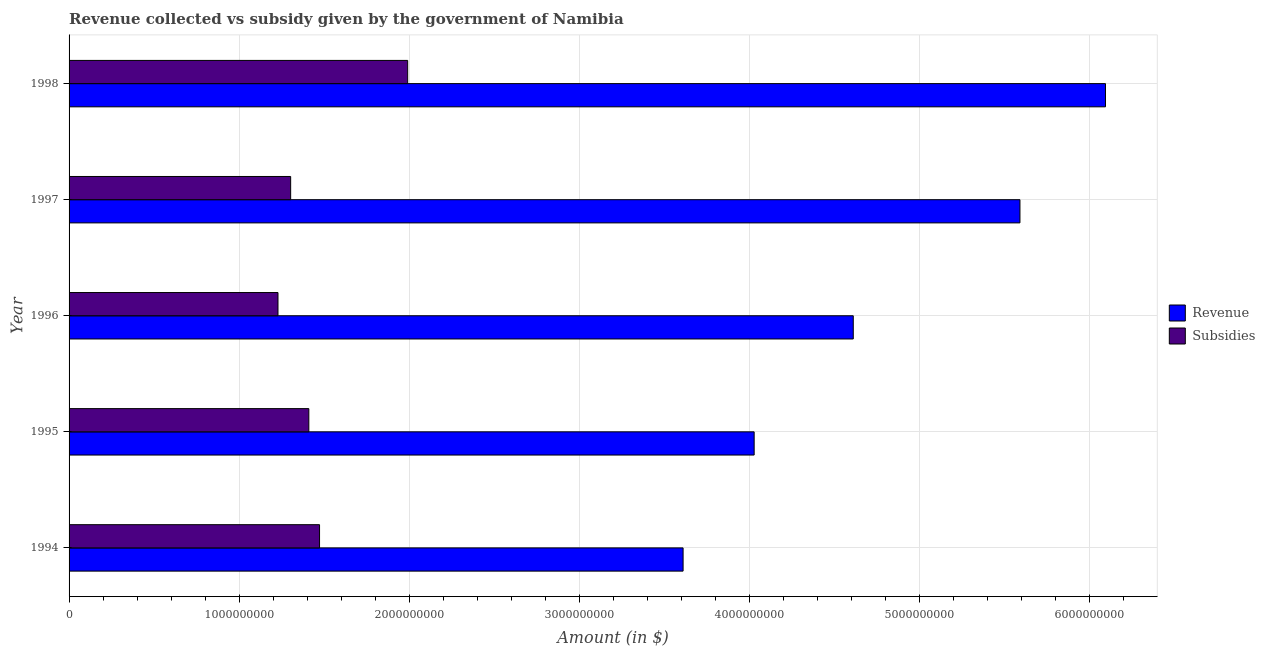How many groups of bars are there?
Give a very brief answer. 5. Are the number of bars on each tick of the Y-axis equal?
Your answer should be very brief. Yes. How many bars are there on the 4th tick from the top?
Give a very brief answer. 2. How many bars are there on the 4th tick from the bottom?
Keep it short and to the point. 2. What is the amount of subsidies given in 1996?
Provide a short and direct response. 1.23e+09. Across all years, what is the maximum amount of subsidies given?
Give a very brief answer. 1.99e+09. Across all years, what is the minimum amount of subsidies given?
Your answer should be compact. 1.23e+09. In which year was the amount of revenue collected maximum?
Make the answer very short. 1998. In which year was the amount of revenue collected minimum?
Ensure brevity in your answer.  1994. What is the total amount of subsidies given in the graph?
Offer a very short reply. 7.41e+09. What is the difference between the amount of subsidies given in 1994 and that in 1995?
Offer a very short reply. 6.31e+07. What is the difference between the amount of subsidies given in 1997 and the amount of revenue collected in 1996?
Keep it short and to the point. -3.31e+09. What is the average amount of revenue collected per year?
Provide a short and direct response. 4.79e+09. In the year 1998, what is the difference between the amount of subsidies given and amount of revenue collected?
Provide a short and direct response. -4.10e+09. What is the ratio of the amount of subsidies given in 1994 to that in 1997?
Your answer should be compact. 1.13. What is the difference between the highest and the second highest amount of subsidies given?
Keep it short and to the point. 5.18e+08. What is the difference between the highest and the lowest amount of subsidies given?
Give a very brief answer. 7.63e+08. Is the sum of the amount of subsidies given in 1994 and 1996 greater than the maximum amount of revenue collected across all years?
Make the answer very short. No. What does the 2nd bar from the top in 1996 represents?
Your answer should be compact. Revenue. What does the 2nd bar from the bottom in 1998 represents?
Provide a succinct answer. Subsidies. How many bars are there?
Offer a terse response. 10. How many years are there in the graph?
Make the answer very short. 5. Are the values on the major ticks of X-axis written in scientific E-notation?
Make the answer very short. No. Does the graph contain grids?
Ensure brevity in your answer.  Yes. How many legend labels are there?
Your response must be concise. 2. What is the title of the graph?
Ensure brevity in your answer.  Revenue collected vs subsidy given by the government of Namibia. What is the label or title of the X-axis?
Provide a succinct answer. Amount (in $). What is the label or title of the Y-axis?
Keep it short and to the point. Year. What is the Amount (in $) in Revenue in 1994?
Keep it short and to the point. 3.61e+09. What is the Amount (in $) in Subsidies in 1994?
Provide a succinct answer. 1.47e+09. What is the Amount (in $) of Revenue in 1995?
Offer a terse response. 4.03e+09. What is the Amount (in $) of Subsidies in 1995?
Your answer should be very brief. 1.41e+09. What is the Amount (in $) of Revenue in 1996?
Give a very brief answer. 4.61e+09. What is the Amount (in $) of Subsidies in 1996?
Provide a succinct answer. 1.23e+09. What is the Amount (in $) of Revenue in 1997?
Ensure brevity in your answer.  5.59e+09. What is the Amount (in $) of Subsidies in 1997?
Your answer should be compact. 1.30e+09. What is the Amount (in $) of Revenue in 1998?
Your response must be concise. 6.09e+09. What is the Amount (in $) in Subsidies in 1998?
Your answer should be very brief. 1.99e+09. Across all years, what is the maximum Amount (in $) of Revenue?
Keep it short and to the point. 6.09e+09. Across all years, what is the maximum Amount (in $) in Subsidies?
Your response must be concise. 1.99e+09. Across all years, what is the minimum Amount (in $) of Revenue?
Offer a terse response. 3.61e+09. Across all years, what is the minimum Amount (in $) of Subsidies?
Give a very brief answer. 1.23e+09. What is the total Amount (in $) in Revenue in the graph?
Your answer should be compact. 2.39e+1. What is the total Amount (in $) of Subsidies in the graph?
Make the answer very short. 7.41e+09. What is the difference between the Amount (in $) in Revenue in 1994 and that in 1995?
Make the answer very short. -4.18e+08. What is the difference between the Amount (in $) in Subsidies in 1994 and that in 1995?
Keep it short and to the point. 6.31e+07. What is the difference between the Amount (in $) of Revenue in 1994 and that in 1996?
Keep it short and to the point. -1.00e+09. What is the difference between the Amount (in $) of Subsidies in 1994 and that in 1996?
Ensure brevity in your answer.  2.44e+08. What is the difference between the Amount (in $) in Revenue in 1994 and that in 1997?
Provide a short and direct response. -1.98e+09. What is the difference between the Amount (in $) of Subsidies in 1994 and that in 1997?
Offer a very short reply. 1.70e+08. What is the difference between the Amount (in $) in Revenue in 1994 and that in 1998?
Offer a very short reply. -2.48e+09. What is the difference between the Amount (in $) of Subsidies in 1994 and that in 1998?
Offer a terse response. -5.18e+08. What is the difference between the Amount (in $) in Revenue in 1995 and that in 1996?
Your answer should be compact. -5.83e+08. What is the difference between the Amount (in $) of Subsidies in 1995 and that in 1996?
Offer a terse response. 1.81e+08. What is the difference between the Amount (in $) in Revenue in 1995 and that in 1997?
Your response must be concise. -1.56e+09. What is the difference between the Amount (in $) of Subsidies in 1995 and that in 1997?
Your response must be concise. 1.07e+08. What is the difference between the Amount (in $) in Revenue in 1995 and that in 1998?
Make the answer very short. -2.07e+09. What is the difference between the Amount (in $) of Subsidies in 1995 and that in 1998?
Your response must be concise. -5.81e+08. What is the difference between the Amount (in $) of Revenue in 1996 and that in 1997?
Your answer should be very brief. -9.80e+08. What is the difference between the Amount (in $) in Subsidies in 1996 and that in 1997?
Offer a terse response. -7.44e+07. What is the difference between the Amount (in $) of Revenue in 1996 and that in 1998?
Your response must be concise. -1.48e+09. What is the difference between the Amount (in $) of Subsidies in 1996 and that in 1998?
Keep it short and to the point. -7.63e+08. What is the difference between the Amount (in $) of Revenue in 1997 and that in 1998?
Ensure brevity in your answer.  -5.03e+08. What is the difference between the Amount (in $) of Subsidies in 1997 and that in 1998?
Your answer should be compact. -6.88e+08. What is the difference between the Amount (in $) of Revenue in 1994 and the Amount (in $) of Subsidies in 1995?
Offer a terse response. 2.20e+09. What is the difference between the Amount (in $) of Revenue in 1994 and the Amount (in $) of Subsidies in 1996?
Offer a very short reply. 2.38e+09. What is the difference between the Amount (in $) of Revenue in 1994 and the Amount (in $) of Subsidies in 1997?
Ensure brevity in your answer.  2.31e+09. What is the difference between the Amount (in $) in Revenue in 1994 and the Amount (in $) in Subsidies in 1998?
Your response must be concise. 1.62e+09. What is the difference between the Amount (in $) of Revenue in 1995 and the Amount (in $) of Subsidies in 1996?
Keep it short and to the point. 2.80e+09. What is the difference between the Amount (in $) of Revenue in 1995 and the Amount (in $) of Subsidies in 1997?
Ensure brevity in your answer.  2.73e+09. What is the difference between the Amount (in $) of Revenue in 1995 and the Amount (in $) of Subsidies in 1998?
Keep it short and to the point. 2.04e+09. What is the difference between the Amount (in $) in Revenue in 1996 and the Amount (in $) in Subsidies in 1997?
Provide a succinct answer. 3.31e+09. What is the difference between the Amount (in $) of Revenue in 1996 and the Amount (in $) of Subsidies in 1998?
Your answer should be compact. 2.62e+09. What is the difference between the Amount (in $) of Revenue in 1997 and the Amount (in $) of Subsidies in 1998?
Keep it short and to the point. 3.60e+09. What is the average Amount (in $) in Revenue per year?
Provide a succinct answer. 4.79e+09. What is the average Amount (in $) of Subsidies per year?
Ensure brevity in your answer.  1.48e+09. In the year 1994, what is the difference between the Amount (in $) in Revenue and Amount (in $) in Subsidies?
Provide a short and direct response. 2.14e+09. In the year 1995, what is the difference between the Amount (in $) of Revenue and Amount (in $) of Subsidies?
Your answer should be very brief. 2.62e+09. In the year 1996, what is the difference between the Amount (in $) in Revenue and Amount (in $) in Subsidies?
Your answer should be very brief. 3.38e+09. In the year 1997, what is the difference between the Amount (in $) in Revenue and Amount (in $) in Subsidies?
Offer a very short reply. 4.29e+09. In the year 1998, what is the difference between the Amount (in $) in Revenue and Amount (in $) in Subsidies?
Keep it short and to the point. 4.10e+09. What is the ratio of the Amount (in $) in Revenue in 1994 to that in 1995?
Offer a very short reply. 0.9. What is the ratio of the Amount (in $) in Subsidies in 1994 to that in 1995?
Keep it short and to the point. 1.04. What is the ratio of the Amount (in $) in Revenue in 1994 to that in 1996?
Ensure brevity in your answer.  0.78. What is the ratio of the Amount (in $) of Subsidies in 1994 to that in 1996?
Offer a very short reply. 1.2. What is the ratio of the Amount (in $) of Revenue in 1994 to that in 1997?
Your answer should be compact. 0.65. What is the ratio of the Amount (in $) in Subsidies in 1994 to that in 1997?
Ensure brevity in your answer.  1.13. What is the ratio of the Amount (in $) of Revenue in 1994 to that in 1998?
Make the answer very short. 0.59. What is the ratio of the Amount (in $) of Subsidies in 1994 to that in 1998?
Provide a succinct answer. 0.74. What is the ratio of the Amount (in $) of Revenue in 1995 to that in 1996?
Provide a short and direct response. 0.87. What is the ratio of the Amount (in $) in Subsidies in 1995 to that in 1996?
Your answer should be compact. 1.15. What is the ratio of the Amount (in $) of Revenue in 1995 to that in 1997?
Offer a terse response. 0.72. What is the ratio of the Amount (in $) in Subsidies in 1995 to that in 1997?
Your response must be concise. 1.08. What is the ratio of the Amount (in $) in Revenue in 1995 to that in 1998?
Give a very brief answer. 0.66. What is the ratio of the Amount (in $) in Subsidies in 1995 to that in 1998?
Make the answer very short. 0.71. What is the ratio of the Amount (in $) in Revenue in 1996 to that in 1997?
Give a very brief answer. 0.82. What is the ratio of the Amount (in $) of Subsidies in 1996 to that in 1997?
Keep it short and to the point. 0.94. What is the ratio of the Amount (in $) in Revenue in 1996 to that in 1998?
Give a very brief answer. 0.76. What is the ratio of the Amount (in $) in Subsidies in 1996 to that in 1998?
Your response must be concise. 0.62. What is the ratio of the Amount (in $) in Revenue in 1997 to that in 1998?
Make the answer very short. 0.92. What is the ratio of the Amount (in $) in Subsidies in 1997 to that in 1998?
Provide a short and direct response. 0.65. What is the difference between the highest and the second highest Amount (in $) in Revenue?
Ensure brevity in your answer.  5.03e+08. What is the difference between the highest and the second highest Amount (in $) in Subsidies?
Your answer should be very brief. 5.18e+08. What is the difference between the highest and the lowest Amount (in $) of Revenue?
Your answer should be compact. 2.48e+09. What is the difference between the highest and the lowest Amount (in $) of Subsidies?
Make the answer very short. 7.63e+08. 